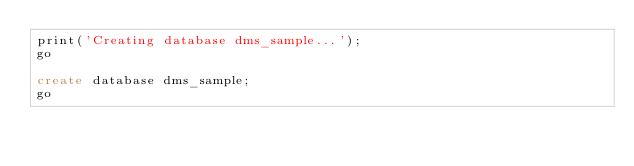Convert code to text. <code><loc_0><loc_0><loc_500><loc_500><_SQL_>print('Creating database dms_sample...');
go

create database dms_sample;
go
</code> 